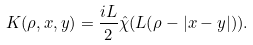<formula> <loc_0><loc_0><loc_500><loc_500>K ( \rho , x , y ) = \frac { i L } { 2 } \hat { \chi } ( L ( \rho - | x - y | ) ) .</formula> 